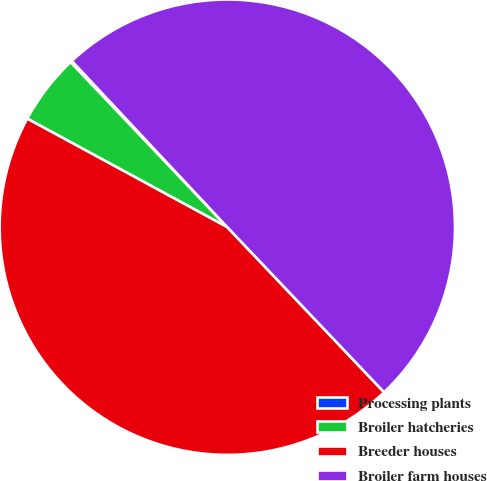Convert chart to OTSL. <chart><loc_0><loc_0><loc_500><loc_500><pie_chart><fcel>Processing plants<fcel>Broiler hatcheries<fcel>Breeder houses<fcel>Broiler farm houses<nl><fcel>0.12%<fcel>5.0%<fcel>45.0%<fcel>49.88%<nl></chart> 